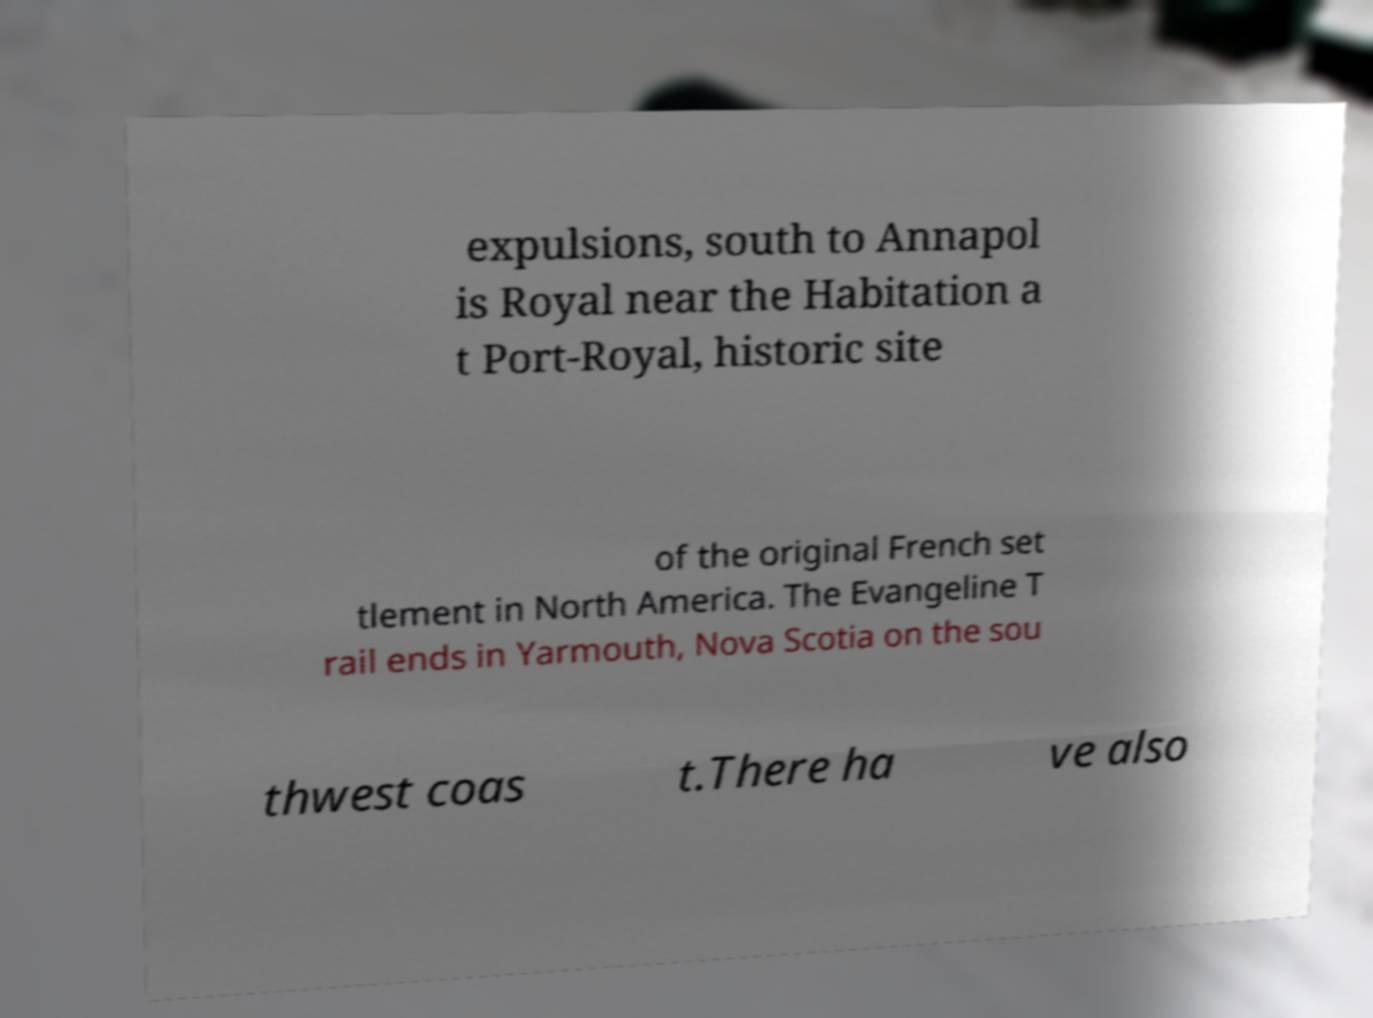What messages or text are displayed in this image? I need them in a readable, typed format. expulsions, south to Annapol is Royal near the Habitation a t Port-Royal, historic site of the original French set tlement in North America. The Evangeline T rail ends in Yarmouth, Nova Scotia on the sou thwest coas t.There ha ve also 